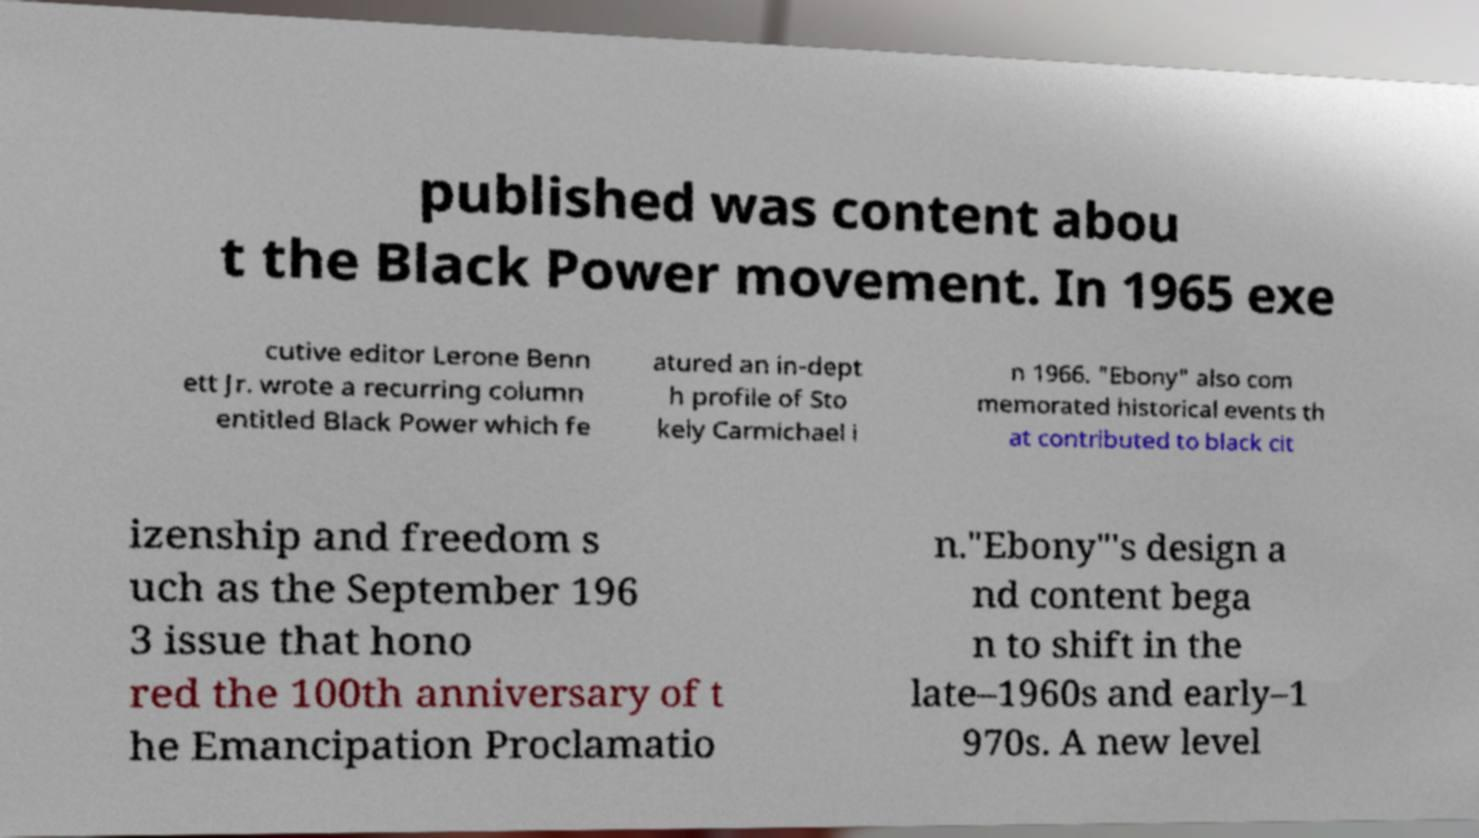Can you read and provide the text displayed in the image?This photo seems to have some interesting text. Can you extract and type it out for me? published was content abou t the Black Power movement. In 1965 exe cutive editor Lerone Benn ett Jr. wrote a recurring column entitled Black Power which fe atured an in-dept h profile of Sto kely Carmichael i n 1966. "Ebony" also com memorated historical events th at contributed to black cit izenship and freedom s uch as the September 196 3 issue that hono red the 100th anniversary of t he Emancipation Proclamatio n."Ebony"'s design a nd content bega n to shift in the late–1960s and early–1 970s. A new level 